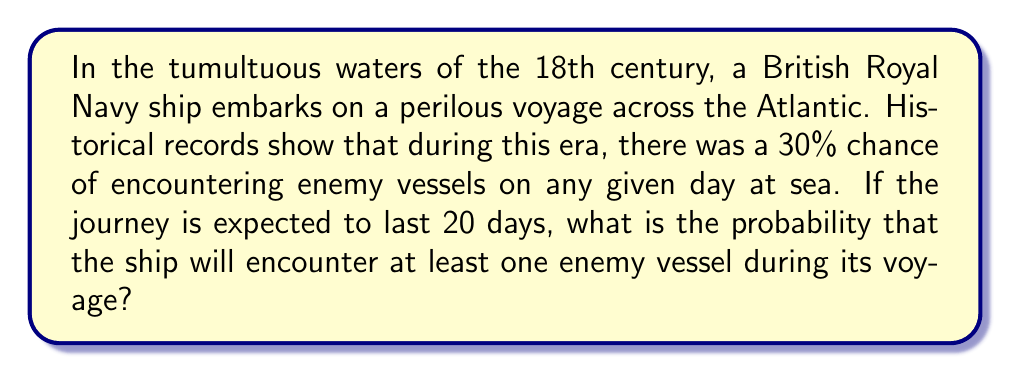Can you answer this question? Let's approach this step-by-step:

1) First, we need to calculate the probability of not encountering any enemy vessels on a single day:
   $P(\text{no encounter on one day}) = 1 - 0.30 = 0.70$ or 70%

2) For the entire 20-day journey, we need to calculate the probability of not encountering any enemy vessels on any of the 20 days:
   $P(\text{no encounters in 20 days}) = (0.70)^{20}$

3) We can calculate this:
   $$(0.70)^{20} \approx 0.0008$$

4) Now, the probability of encountering at least one enemy vessel is the complement of not encountering any:
   $$P(\text{at least one encounter}) = 1 - P(\text{no encounters in 20 days})$$
   $$= 1 - (0.70)^{20}$$
   $$= 1 - 0.0008$$
   $$= 0.9992$$

5) Converting to a percentage:
   $0.9992 \times 100\% = 99.92\%$

Thus, there is a 99.92% chance that the ship will encounter at least one enemy vessel during its 20-day voyage.
Answer: 99.92% 